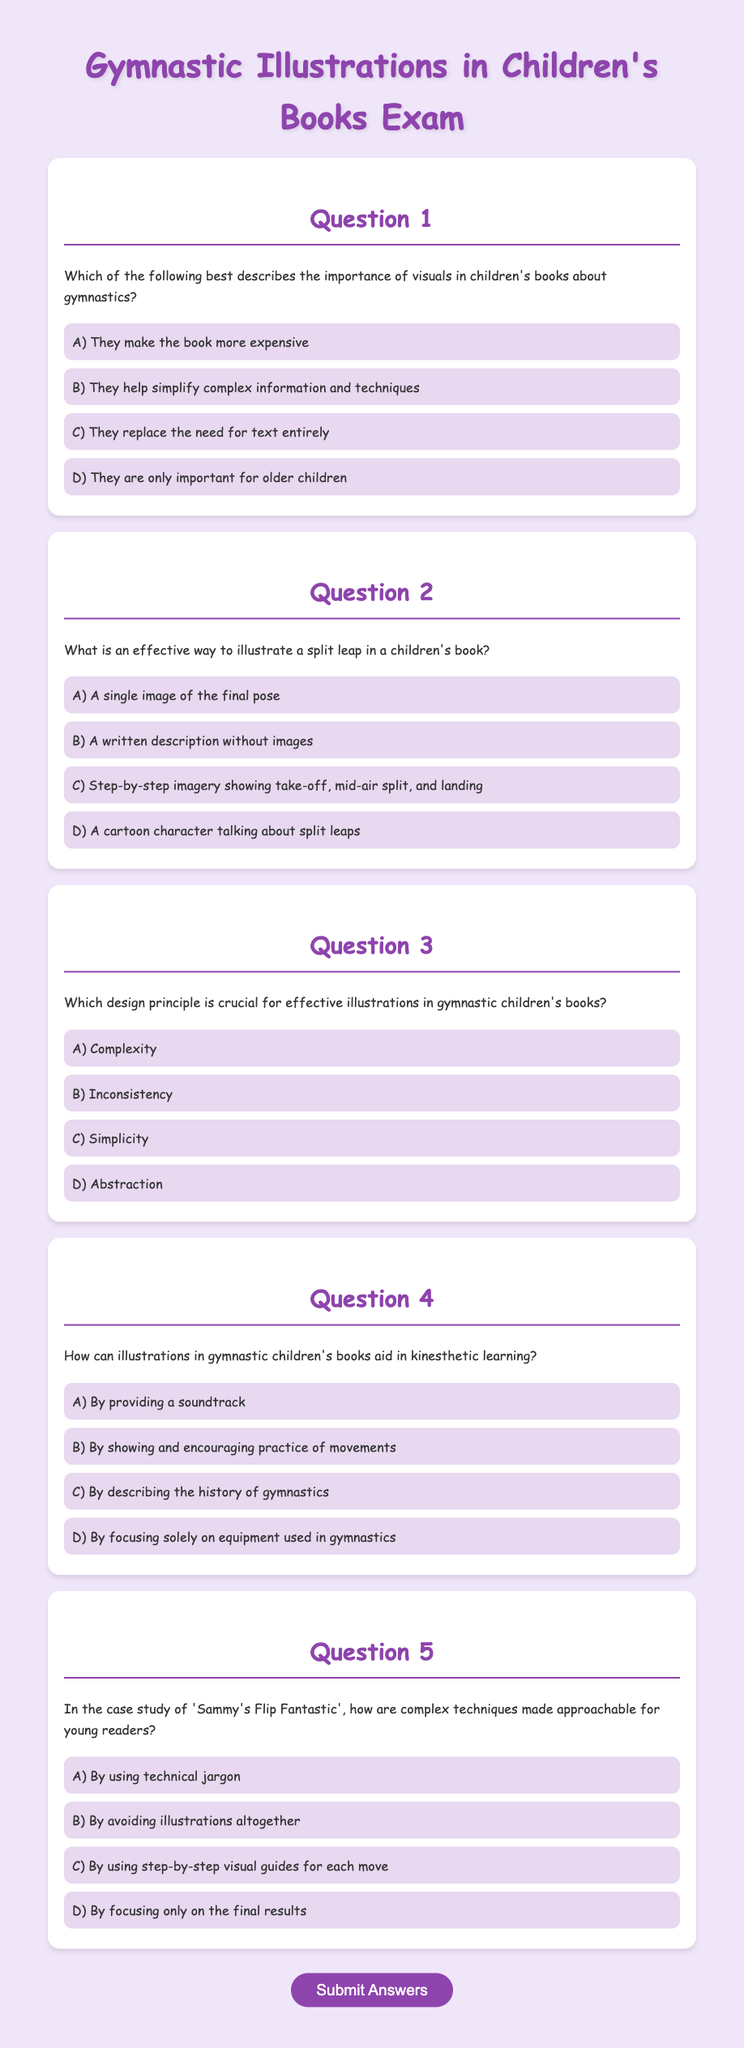What is the title of the exam? The title of the exam is found in the header section of the document.
Answer: Gymnastic Illustrations in Children's Books Exam How many questions are in the exam? The number of questions can be counted by looking at the sections in the document.
Answer: 5 What is the color of the header text? The color of the header text is specified in the CSS styles for the header elements.
Answer: #8e44ad What is the best option for illustrating a split leap? The best option can be determined by reviewing the answer choices provided in question 2.
Answer: Step-by-step imagery showing take-off, mid-air split, and landing Which design principle is emphasized for illustrations? The document includes a question about which design principle is crucial for effective illustrations.
Answer: Simplicity How are complex techniques made approachable in 'Sammy's Flip Fantastic'? The answer is found by interpreting the question regarding the case study in the exam text.
Answer: By using step-by-step visual guides for each move 